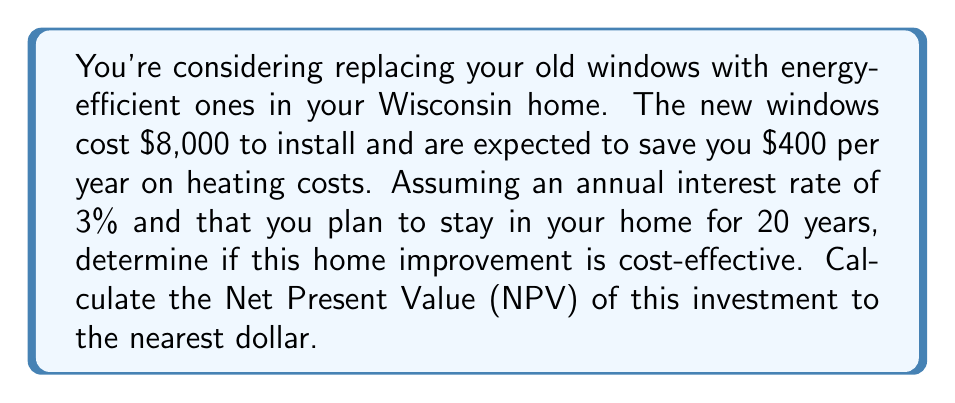What is the answer to this math problem? To determine if this home improvement is cost-effective, we need to calculate the Net Present Value (NPV) of the investment. The NPV compares the present value of all future cash inflows to the initial investment.

Step 1: Identify the components
- Initial investment (C) = $8,000
- Annual savings (A) = $400
- Interest rate (r) = 3% = 0.03
- Time period (n) = 20 years

Step 2: Calculate the Present Value of future savings
We use the formula for the present value of an annuity:

$$ PV = A \cdot \frac{1 - (1+r)^{-n}}{r} $$

Plugging in our values:

$$ PV = 400 \cdot \frac{1 - (1+0.03)^{-20}}{0.03} $$

Step 3: Calculate the result
Using a calculator or spreadsheet:

$$ PV = 400 \cdot 14.8775 = 5,951 $$

Step 4: Calculate the NPV
NPV = Present Value of future savings - Initial investment

$$ NPV = 5,951 - 8,000 = -2,049 $$

Step 5: Interpret the result
Since the NPV is negative, this investment is not cost-effective over the 20-year period given the 3% interest rate.
Answer: $-2,049 